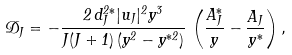Convert formula to latex. <formula><loc_0><loc_0><loc_500><loc_500>\mathcal { D } _ { J } = - \frac { 2 \, d ^ { 2 * } _ { J } | u _ { J } | ^ { 2 } y ^ { 3 } } { J ( J + 1 ) \, ( y ^ { 2 } - y ^ { * 2 } ) } \, \left ( \frac { A ^ { * } _ { J } } { y } - \frac { A _ { J } } { y ^ { * } } \right ) ,</formula> 